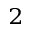Convert formula to latex. <formula><loc_0><loc_0><loc_500><loc_500>^ { 2 }</formula> 